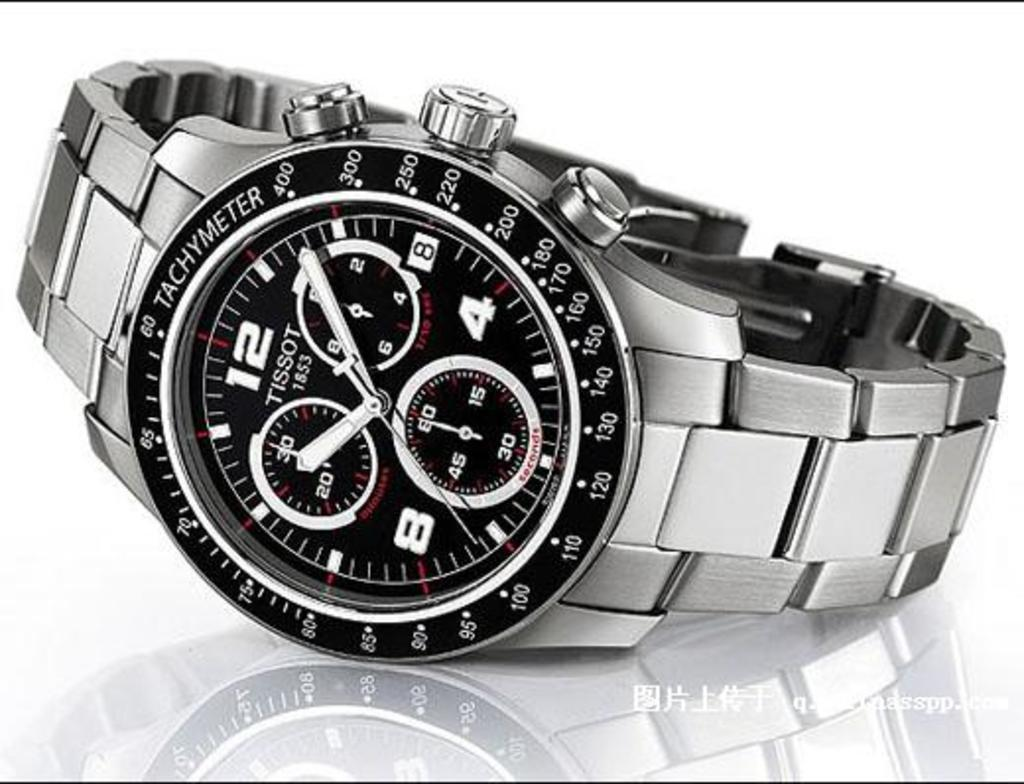Provide a one-sentence caption for the provided image. Black and silver watch which has the name TISSOT on the face. 